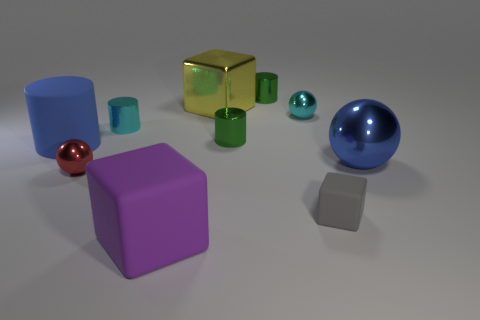Can you tell me which objects have a reflective surface? Sure! The gold cube, both the blue and green cylinders, and all three spheres have reflective surfaces, showing clear highlights and specular reflections. 